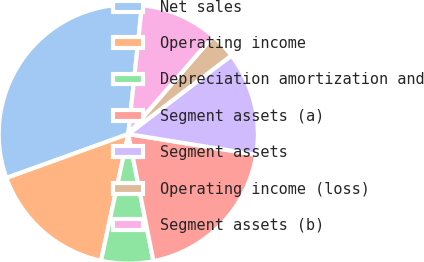<chart> <loc_0><loc_0><loc_500><loc_500><pie_chart><fcel>Net sales<fcel>Operating income<fcel>Depreciation amortization and<fcel>Segment assets (a)<fcel>Segment assets<fcel>Operating income (loss)<fcel>Segment assets (b)<nl><fcel>32.19%<fcel>16.12%<fcel>6.48%<fcel>19.34%<fcel>12.91%<fcel>3.26%<fcel>9.69%<nl></chart> 